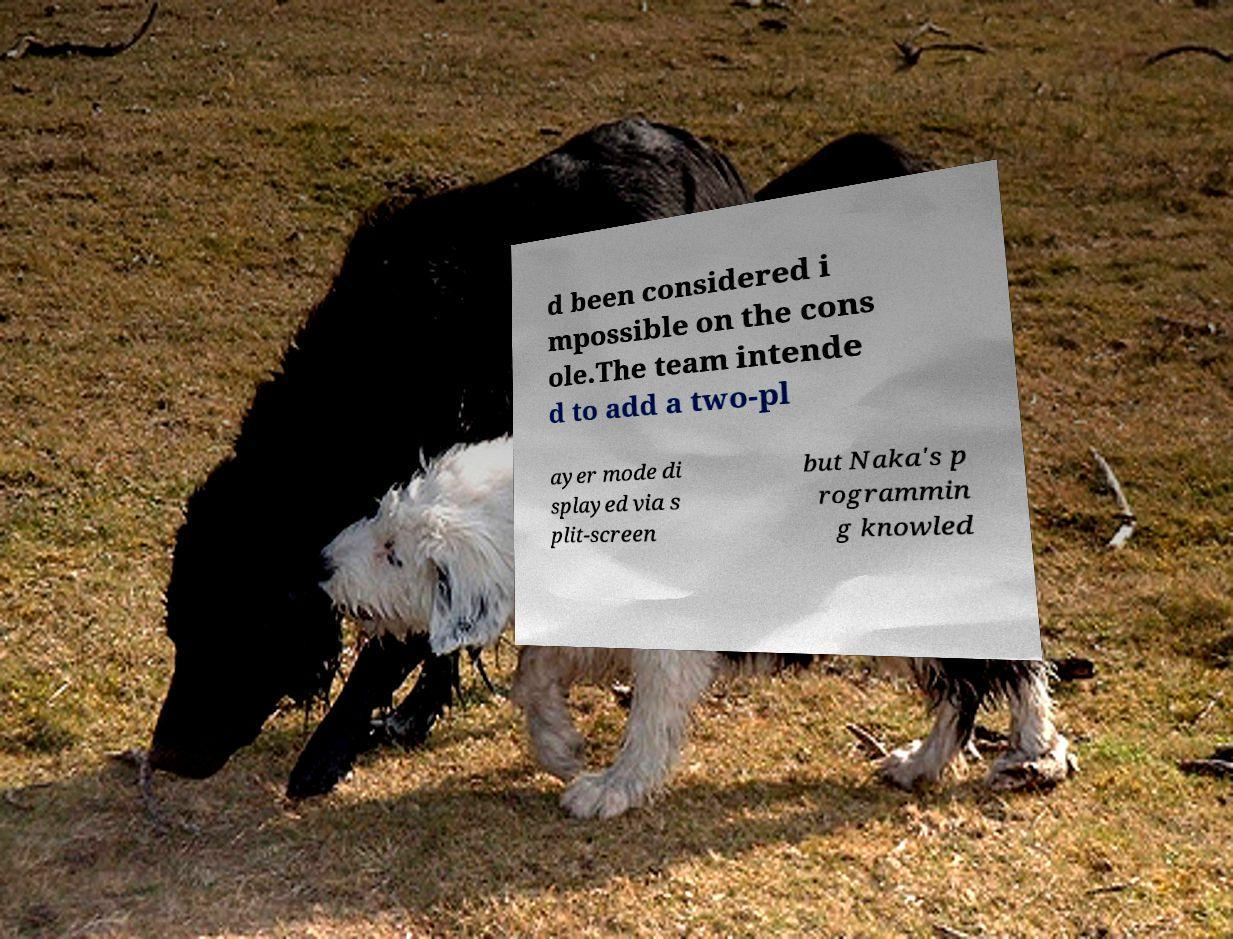There's text embedded in this image that I need extracted. Can you transcribe it verbatim? d been considered i mpossible on the cons ole.The team intende d to add a two-pl ayer mode di splayed via s plit-screen but Naka's p rogrammin g knowled 